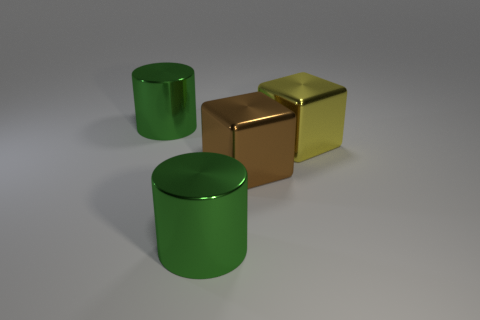Add 2 green objects. How many objects exist? 6 Add 4 metallic objects. How many metallic objects exist? 8 Subtract 0 gray cylinders. How many objects are left? 4 Subtract all green metallic cylinders. Subtract all yellow metallic blocks. How many objects are left? 1 Add 3 yellow metal objects. How many yellow metal objects are left? 4 